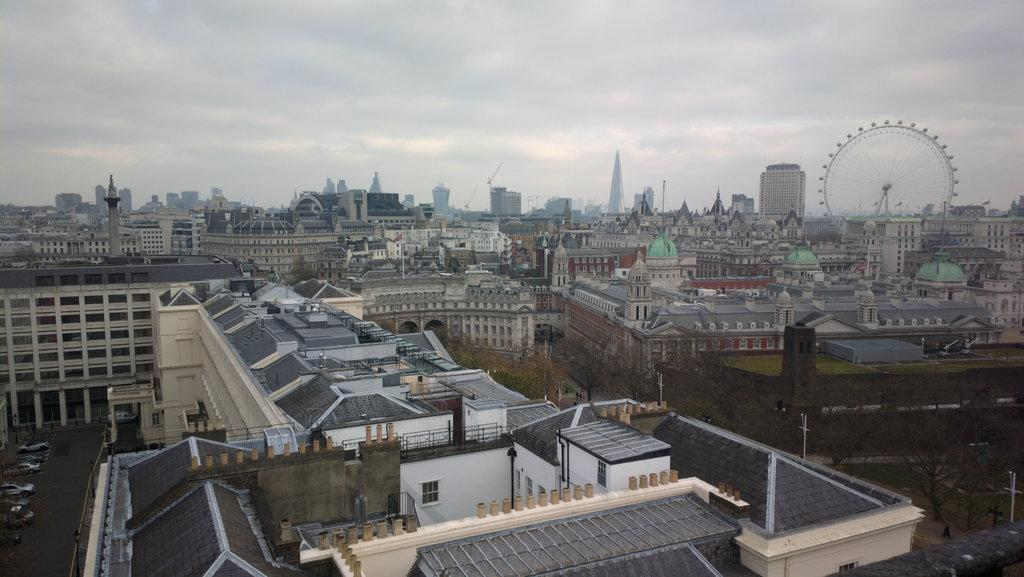What type of structures can be seen in the image? There are buildings in the image. What type of vehicles are present in the image? There are cars in the image. What type of pathways are visible in the image? There are roads in the image. What type of amusement ride can be seen in the image? There is a giant wheel in the image. What type of tall structure is present in the image? There is a tower in the image. What type of natural elements are visible in the image? There are trees in the image. What part of the natural environment is visible in the image? The sky is visible in the image. What type of atmospheric conditions can be seen in the sky? There are clouds in the image. What type of power source is connected to the giant wheel in the image? There is no information about a power source connected to the giant wheel in the image. What type of knowledge can be gained from the tower in the image? The tower in the image is not described as a source of knowledge, so it cannot be determined from the image. 